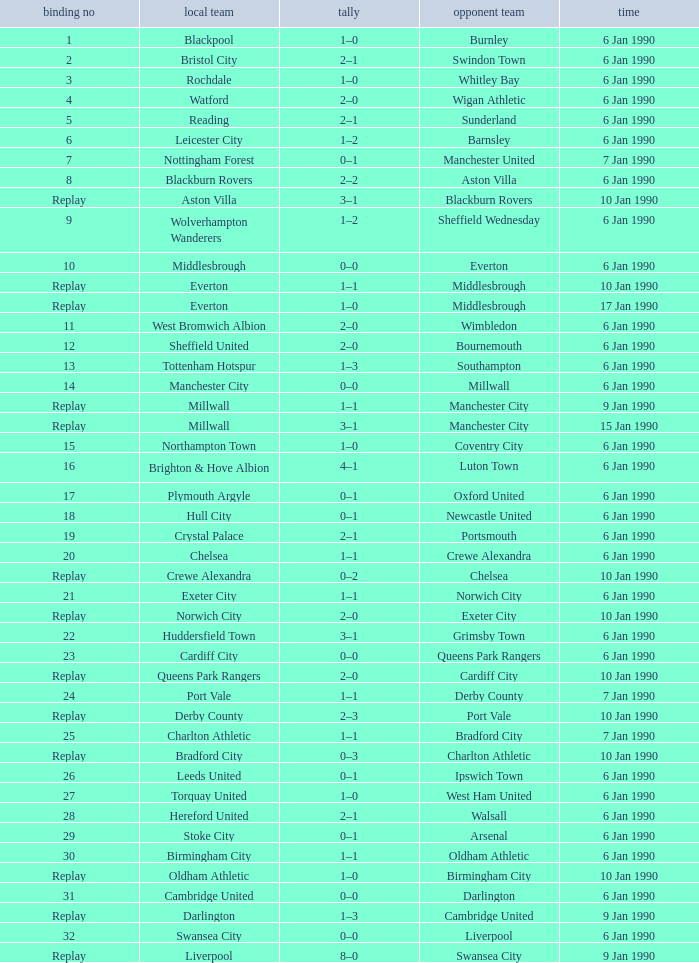What date did home team liverpool play? 9 Jan 1990. 